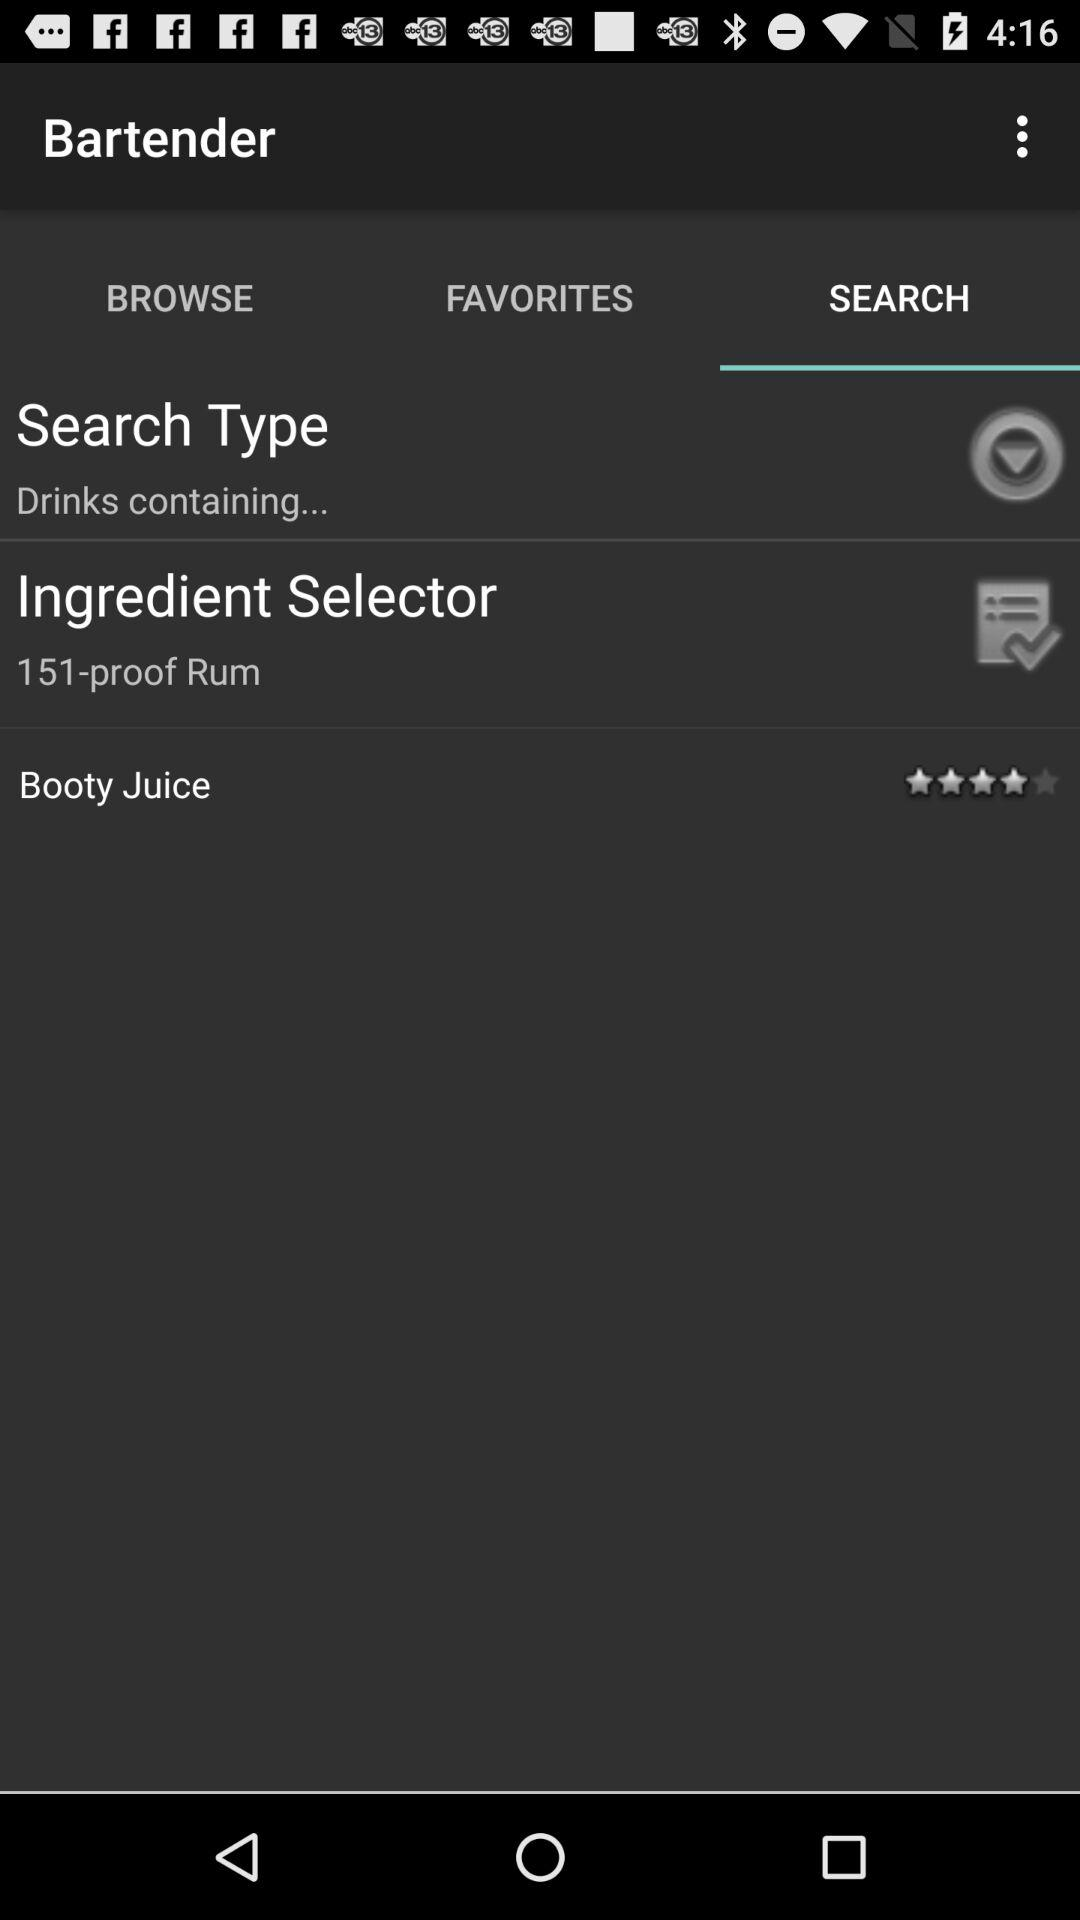What is the rating of "Booty Juice"? The rating is 4 stars. 